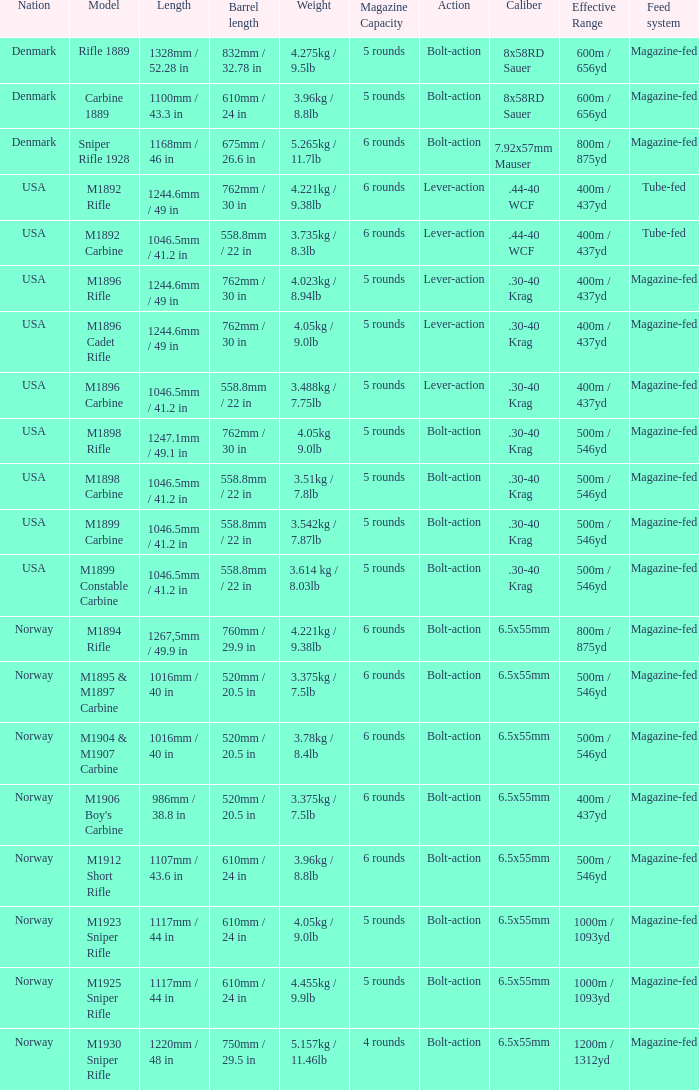What is Weight, when Length is 1168mm / 46 in? 5.265kg / 11.7lb. 